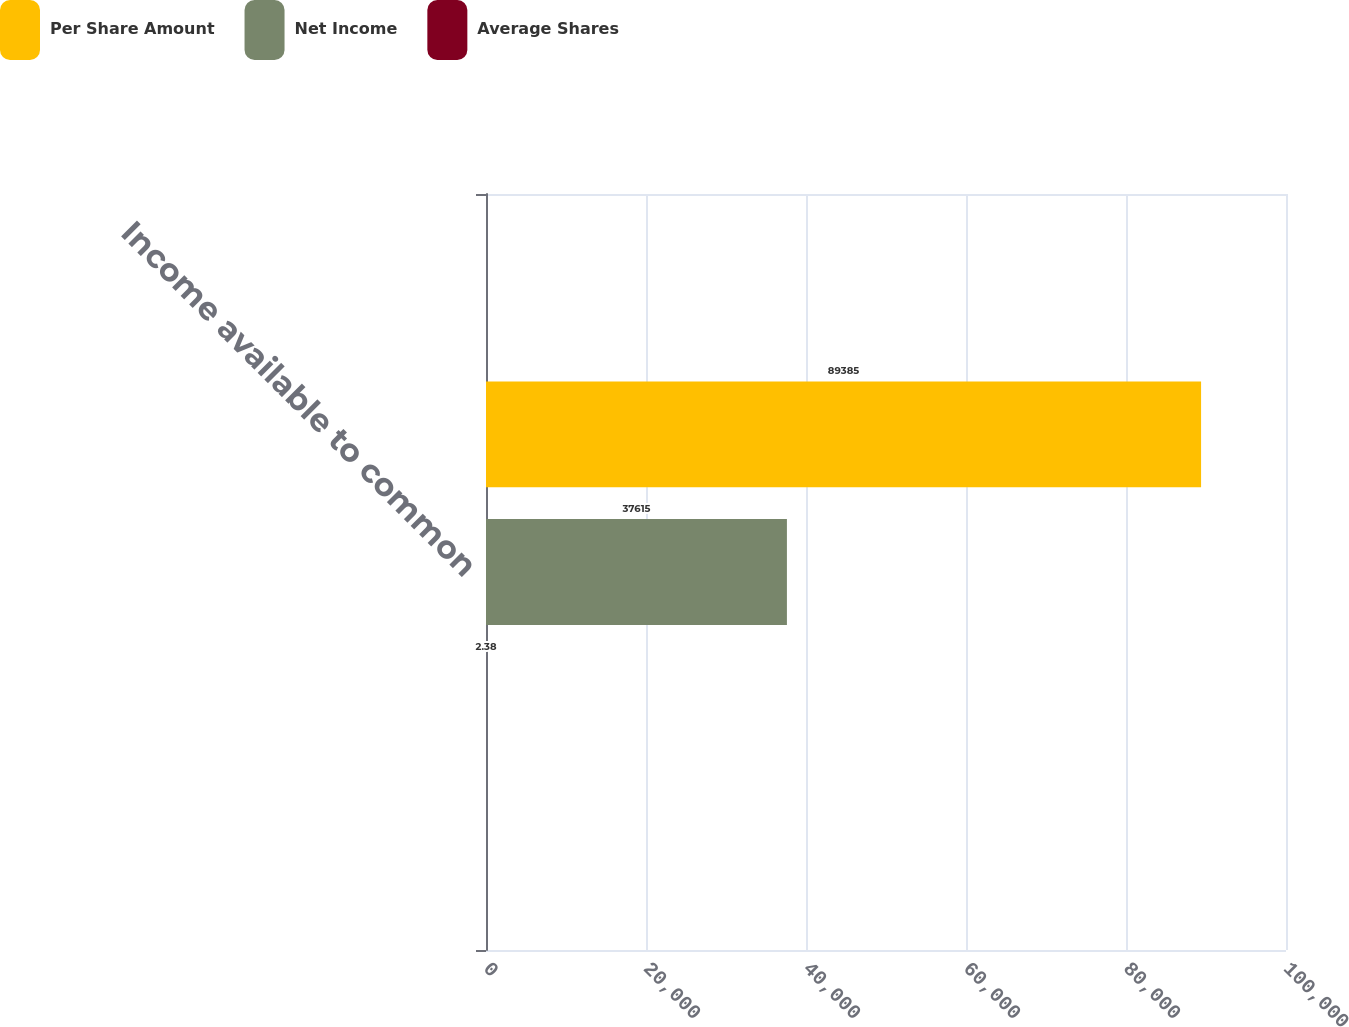<chart> <loc_0><loc_0><loc_500><loc_500><stacked_bar_chart><ecel><fcel>Income available to common<nl><fcel>Per Share Amount<fcel>89385<nl><fcel>Net Income<fcel>37615<nl><fcel>Average Shares<fcel>2.38<nl></chart> 